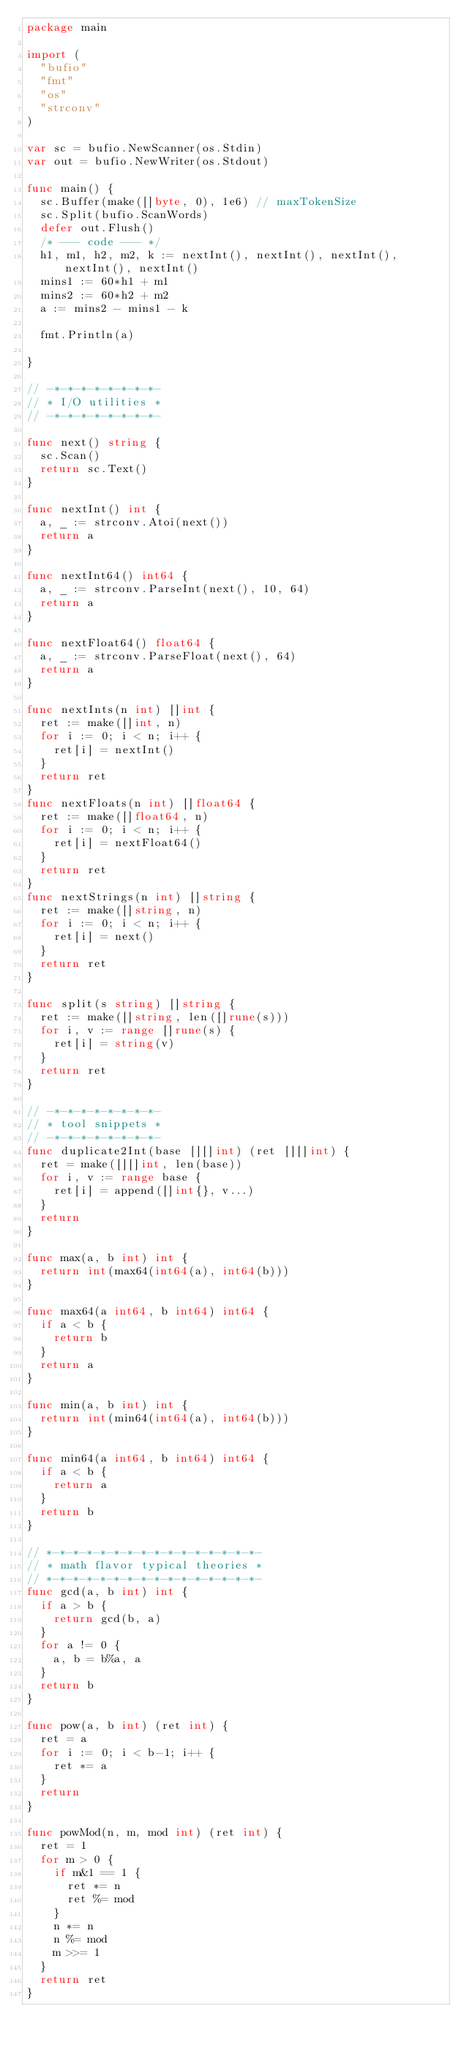<code> <loc_0><loc_0><loc_500><loc_500><_Go_>package main

import (
	"bufio"
	"fmt"
	"os"
	"strconv"
)

var sc = bufio.NewScanner(os.Stdin)
var out = bufio.NewWriter(os.Stdout)

func main() {
	sc.Buffer(make([]byte, 0), 1e6) // maxTokenSize
	sc.Split(bufio.ScanWords)
	defer out.Flush()
	/* --- code --- */
	h1, m1, h2, m2, k := nextInt(), nextInt(), nextInt(), nextInt(), nextInt()
	mins1 := 60*h1 + m1
	mins2 := 60*h2 + m2
	a := mins2 - mins1 - k

	fmt.Println(a)

}

// -*-*-*-*-*-*-*-*-
// * I/O utilities *
// -*-*-*-*-*-*-*-*-

func next() string {
	sc.Scan()
	return sc.Text()
}

func nextInt() int {
	a, _ := strconv.Atoi(next())
	return a
}

func nextInt64() int64 {
	a, _ := strconv.ParseInt(next(), 10, 64)
	return a
}

func nextFloat64() float64 {
	a, _ := strconv.ParseFloat(next(), 64)
	return a
}

func nextInts(n int) []int {
	ret := make([]int, n)
	for i := 0; i < n; i++ {
		ret[i] = nextInt()
	}
	return ret
}
func nextFloats(n int) []float64 {
	ret := make([]float64, n)
	for i := 0; i < n; i++ {
		ret[i] = nextFloat64()
	}
	return ret
}
func nextStrings(n int) []string {
	ret := make([]string, n)
	for i := 0; i < n; i++ {
		ret[i] = next()
	}
	return ret
}

func split(s string) []string {
	ret := make([]string, len([]rune(s)))
	for i, v := range []rune(s) {
		ret[i] = string(v)
	}
	return ret
}

// -*-*-*-*-*-*-*-*-
// * tool snippets *
// -*-*-*-*-*-*-*-*-
func duplicate2Int(base [][]int) (ret [][]int) {
	ret = make([][]int, len(base))
	for i, v := range base {
		ret[i] = append([]int{}, v...)
	}
	return
}

func max(a, b int) int {
	return int(max64(int64(a), int64(b)))
}

func max64(a int64, b int64) int64 {
	if a < b {
		return b
	}
	return a
}

func min(a, b int) int {
	return int(min64(int64(a), int64(b)))
}

func min64(a int64, b int64) int64 {
	if a < b {
		return a
	}
	return b
}

// *-*-*-*-*-*-*-*-*-*-*-*-*-*-*-*-
// * math flavor typical theories *
// *-*-*-*-*-*-*-*-*-*-*-*-*-*-*-*-
func gcd(a, b int) int {
	if a > b {
		return gcd(b, a)
	}
	for a != 0 {
		a, b = b%a, a
	}
	return b
}

func pow(a, b int) (ret int) {
	ret = a
	for i := 0; i < b-1; i++ {
		ret *= a
	}
	return
}

func powMod(n, m, mod int) (ret int) {
	ret = 1
	for m > 0 {
		if m&1 == 1 {
			ret *= n
			ret %= mod
		}
		n *= n
		n %= mod
		m >>= 1
	}
	return ret
}
</code> 